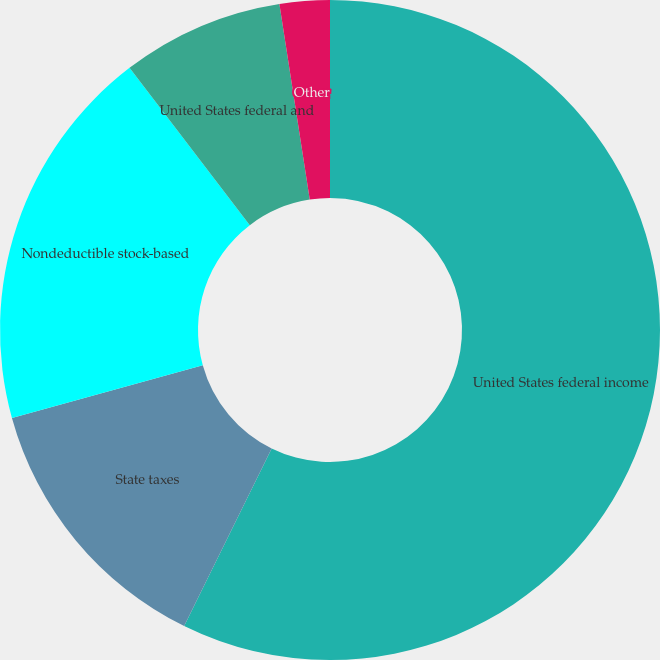Convert chart. <chart><loc_0><loc_0><loc_500><loc_500><pie_chart><fcel>United States federal income<fcel>State taxes<fcel>Nondeductible stock-based<fcel>United States federal and<fcel>Other<nl><fcel>57.28%<fcel>13.42%<fcel>18.9%<fcel>7.94%<fcel>2.45%<nl></chart> 